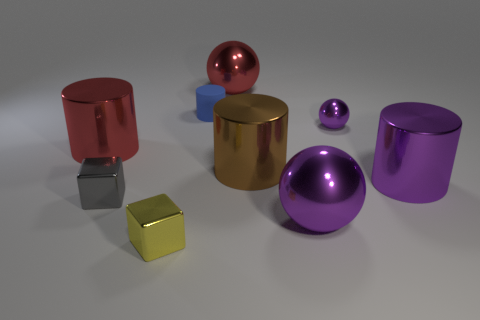Subtract all red cylinders. How many purple spheres are left? 2 Subtract all purple shiny spheres. How many spheres are left? 1 Subtract 1 balls. How many balls are left? 2 Subtract all blue cylinders. How many cylinders are left? 3 Add 1 rubber objects. How many objects exist? 10 Subtract all cylinders. How many objects are left? 5 Subtract all yellow balls. Subtract all purple cylinders. How many balls are left? 3 Subtract all large blue blocks. Subtract all tiny blue matte objects. How many objects are left? 8 Add 5 small metallic things. How many small metallic things are left? 8 Add 5 small gray metallic blocks. How many small gray metallic blocks exist? 6 